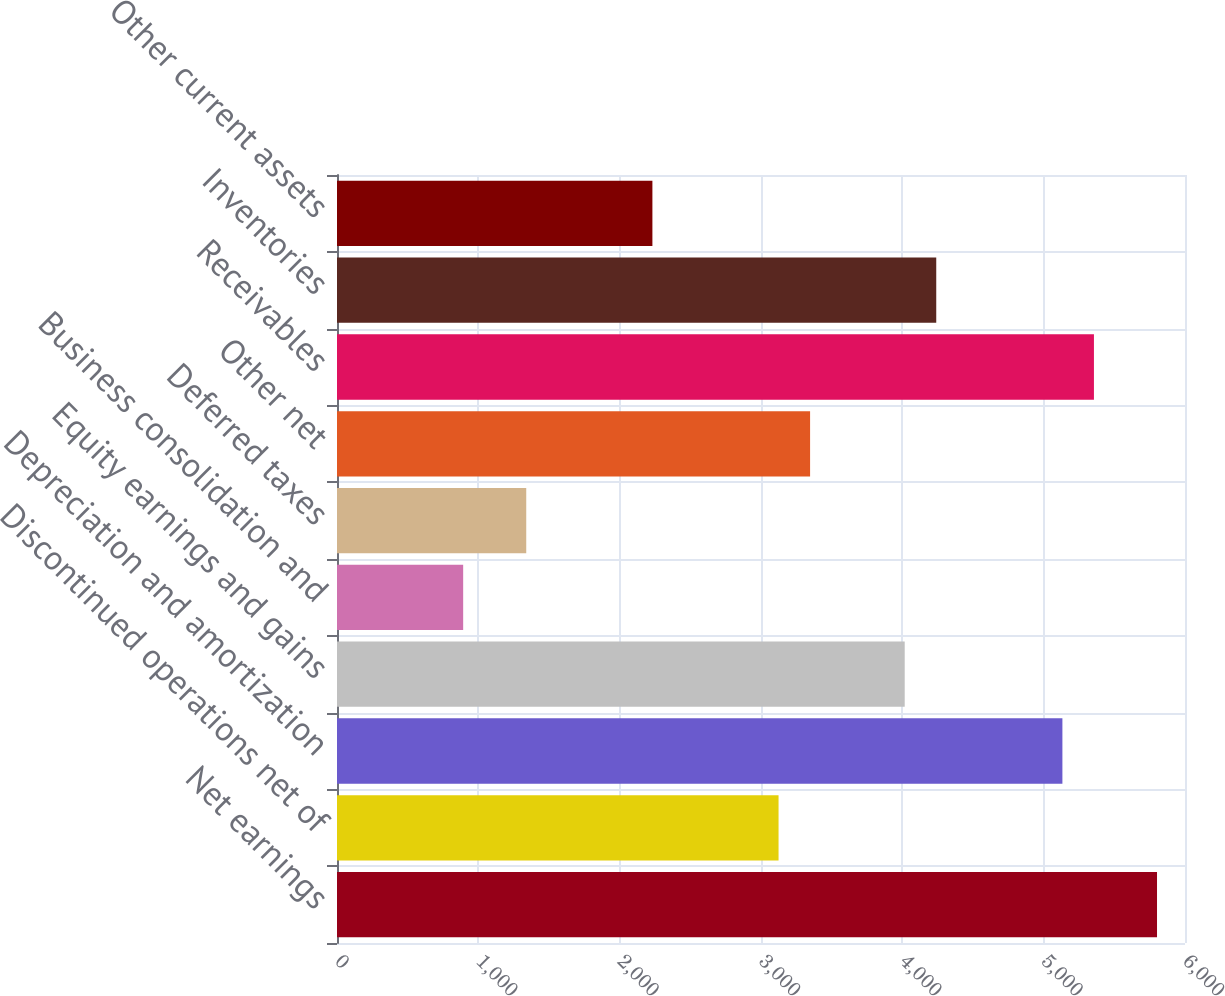Convert chart to OTSL. <chart><loc_0><loc_0><loc_500><loc_500><bar_chart><fcel>Net earnings<fcel>Discontinued operations net of<fcel>Depreciation and amortization<fcel>Equity earnings and gains<fcel>Business consolidation and<fcel>Deferred taxes<fcel>Other net<fcel>Receivables<fcel>Inventories<fcel>Other current assets<nl><fcel>5802<fcel>3124.2<fcel>5132.55<fcel>4016.8<fcel>892.7<fcel>1339<fcel>3347.35<fcel>5355.7<fcel>4239.95<fcel>2231.6<nl></chart> 